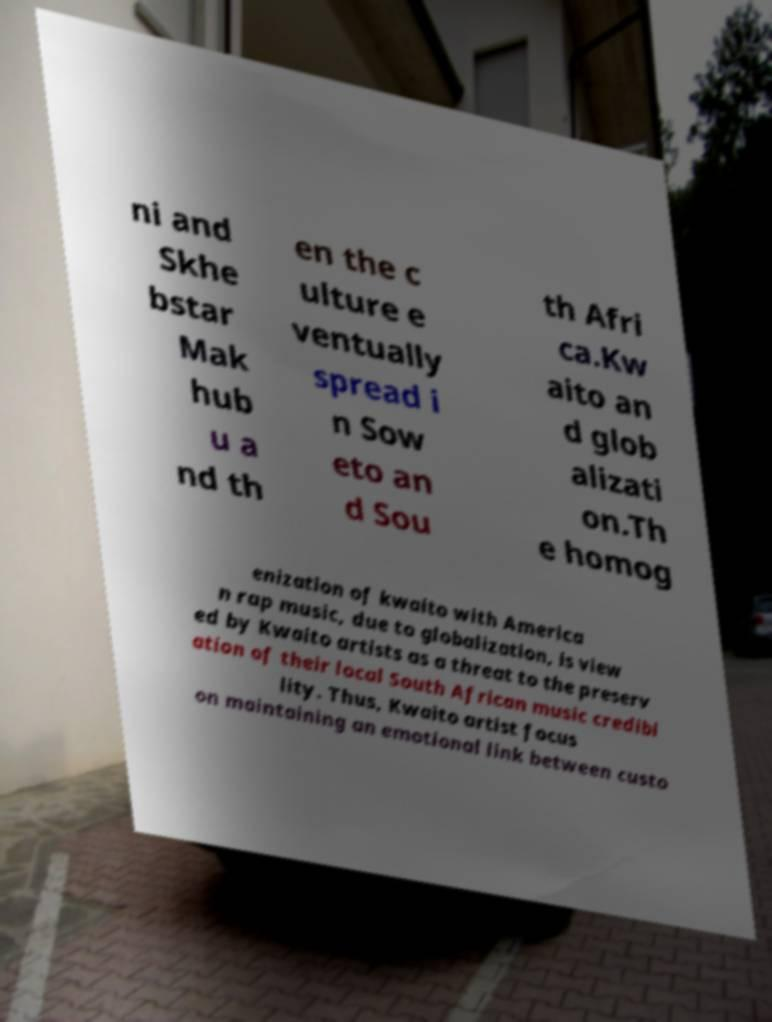There's text embedded in this image that I need extracted. Can you transcribe it verbatim? ni and Skhe bstar Mak hub u a nd th en the c ulture e ventually spread i n Sow eto an d Sou th Afri ca.Kw aito an d glob alizati on.Th e homog enization of kwaito with America n rap music, due to globalization, is view ed by Kwaito artists as a threat to the preserv ation of their local South African music credibi lity. Thus, Kwaito artist focus on maintaining an emotional link between custo 